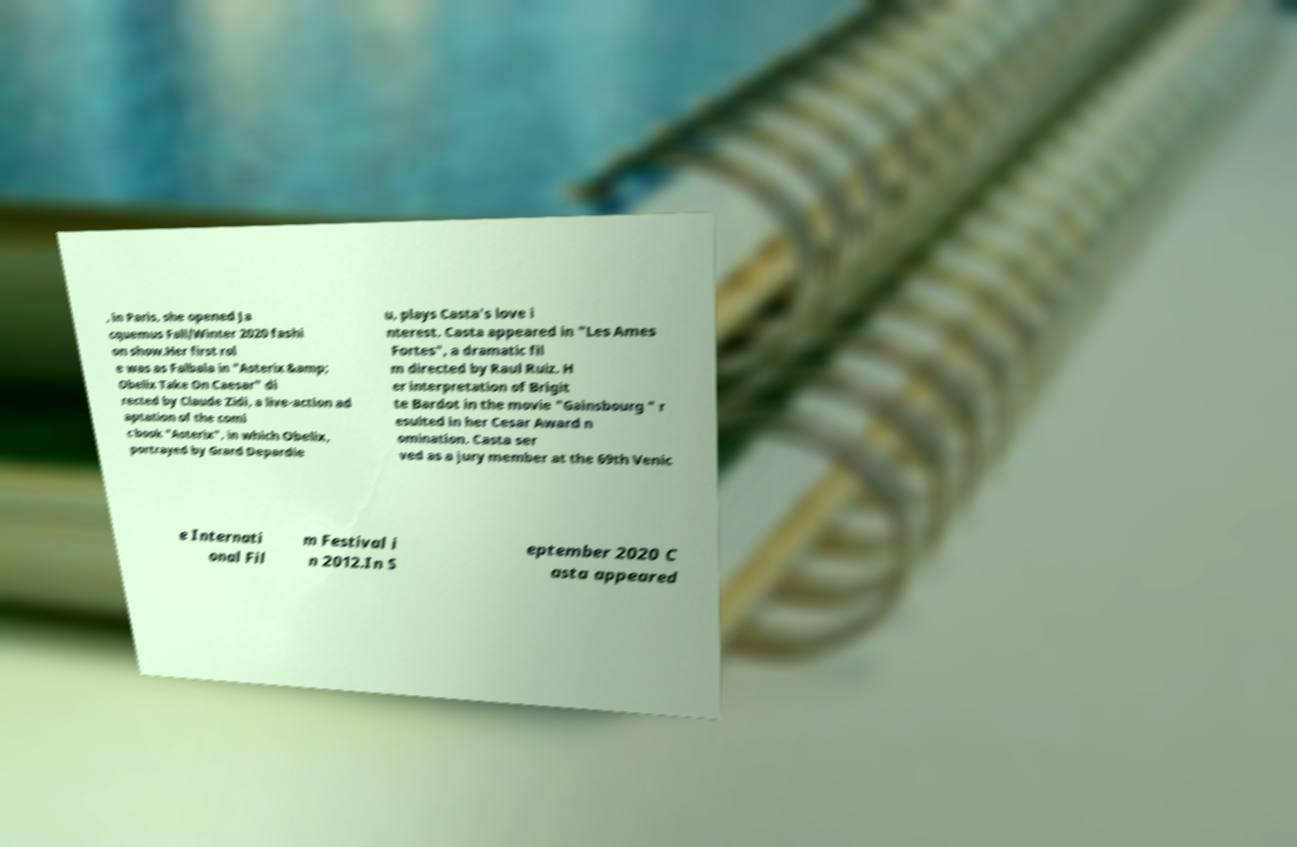What messages or text are displayed in this image? I need them in a readable, typed format. , in Paris, she opened Ja cquemus Fall/Winter 2020 fashi on show.Her first rol e was as Falbala in "Asterix &amp; Obelix Take On Caesar" di rected by Claude Zidi, a live-action ad aptation of the comi c book "Asterix", in which Obelix, portrayed by Grard Depardie u, plays Casta's love i nterest. Casta appeared in "Les Ames Fortes", a dramatic fil m directed by Raul Ruiz. H er interpretation of Brigit te Bardot in the movie "Gainsbourg " r esulted in her Cesar Award n omination. Casta ser ved as a jury member at the 69th Venic e Internati onal Fil m Festival i n 2012.In S eptember 2020 C asta appeared 